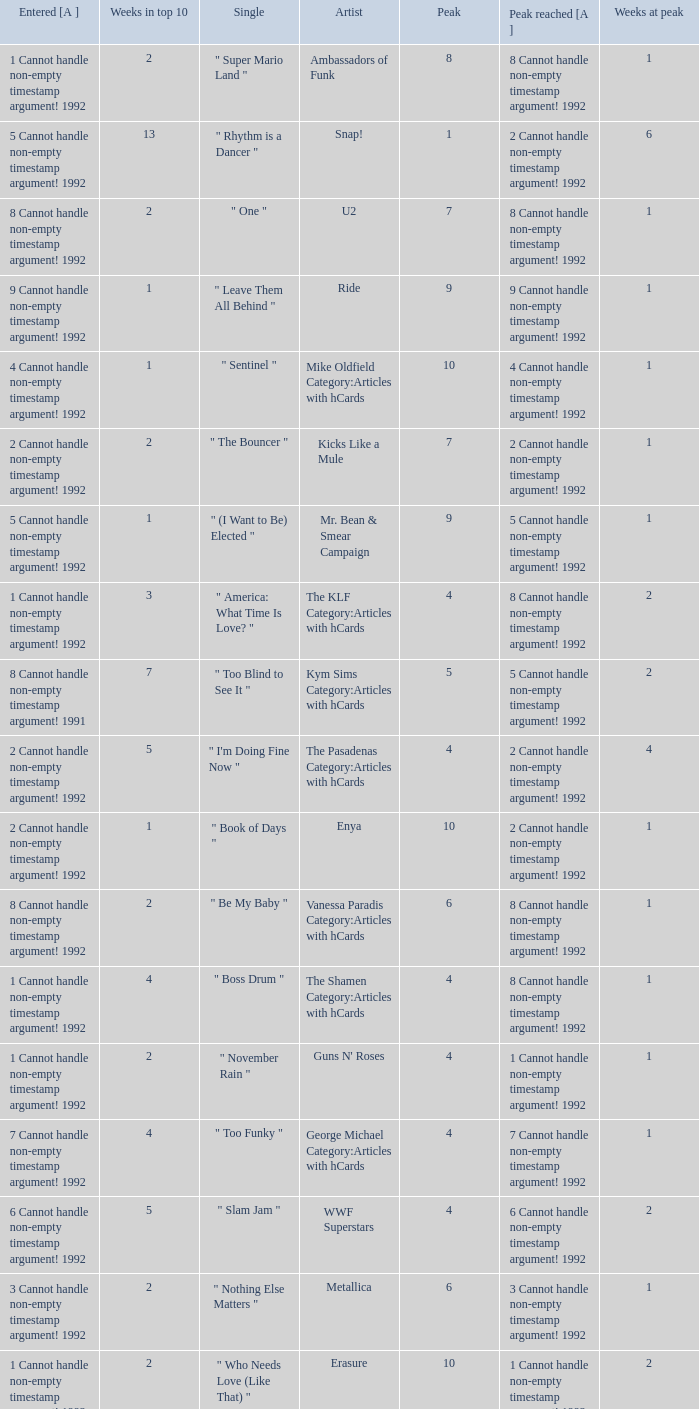What was the peak reached for a single with 4 weeks in the top 10 and entered in 7 cannot handle non-empty timestamp argument! 1992? 7 Cannot handle non-empty timestamp argument! 1992. 